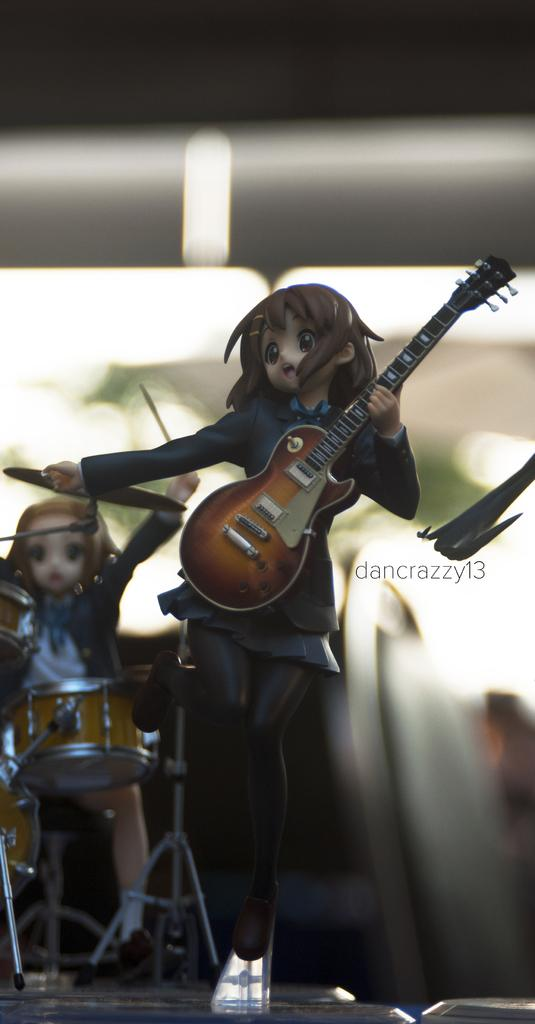What is the main activity being depicted in the image? The main activity in the image is music-related, as there is a person holding a guitar and another person playing drums. Can you describe the instruments being played in the image? Yes, one person is holding a guitar, and the other person is playing drums. Is the person holding the guitar an expert in playing the letter "A" in sign language? There is no indication in the image that the person holding the guitar is involved in sign language or any other activity besides playing the guitar. 